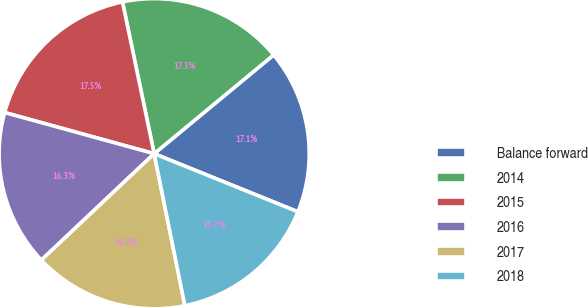Convert chart. <chart><loc_0><loc_0><loc_500><loc_500><pie_chart><fcel>Balance forward<fcel>2014<fcel>2015<fcel>2016<fcel>2017<fcel>2018<nl><fcel>17.11%<fcel>17.28%<fcel>17.45%<fcel>16.31%<fcel>16.14%<fcel>15.71%<nl></chart> 